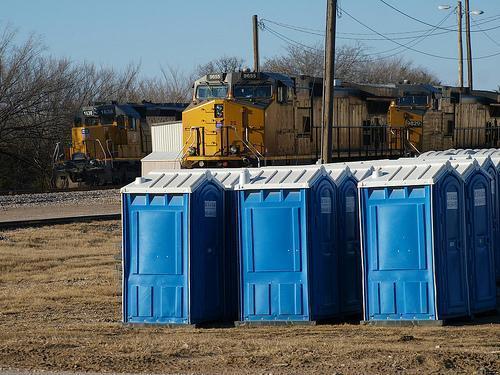How many portable potties are pink?
Give a very brief answer. 0. 